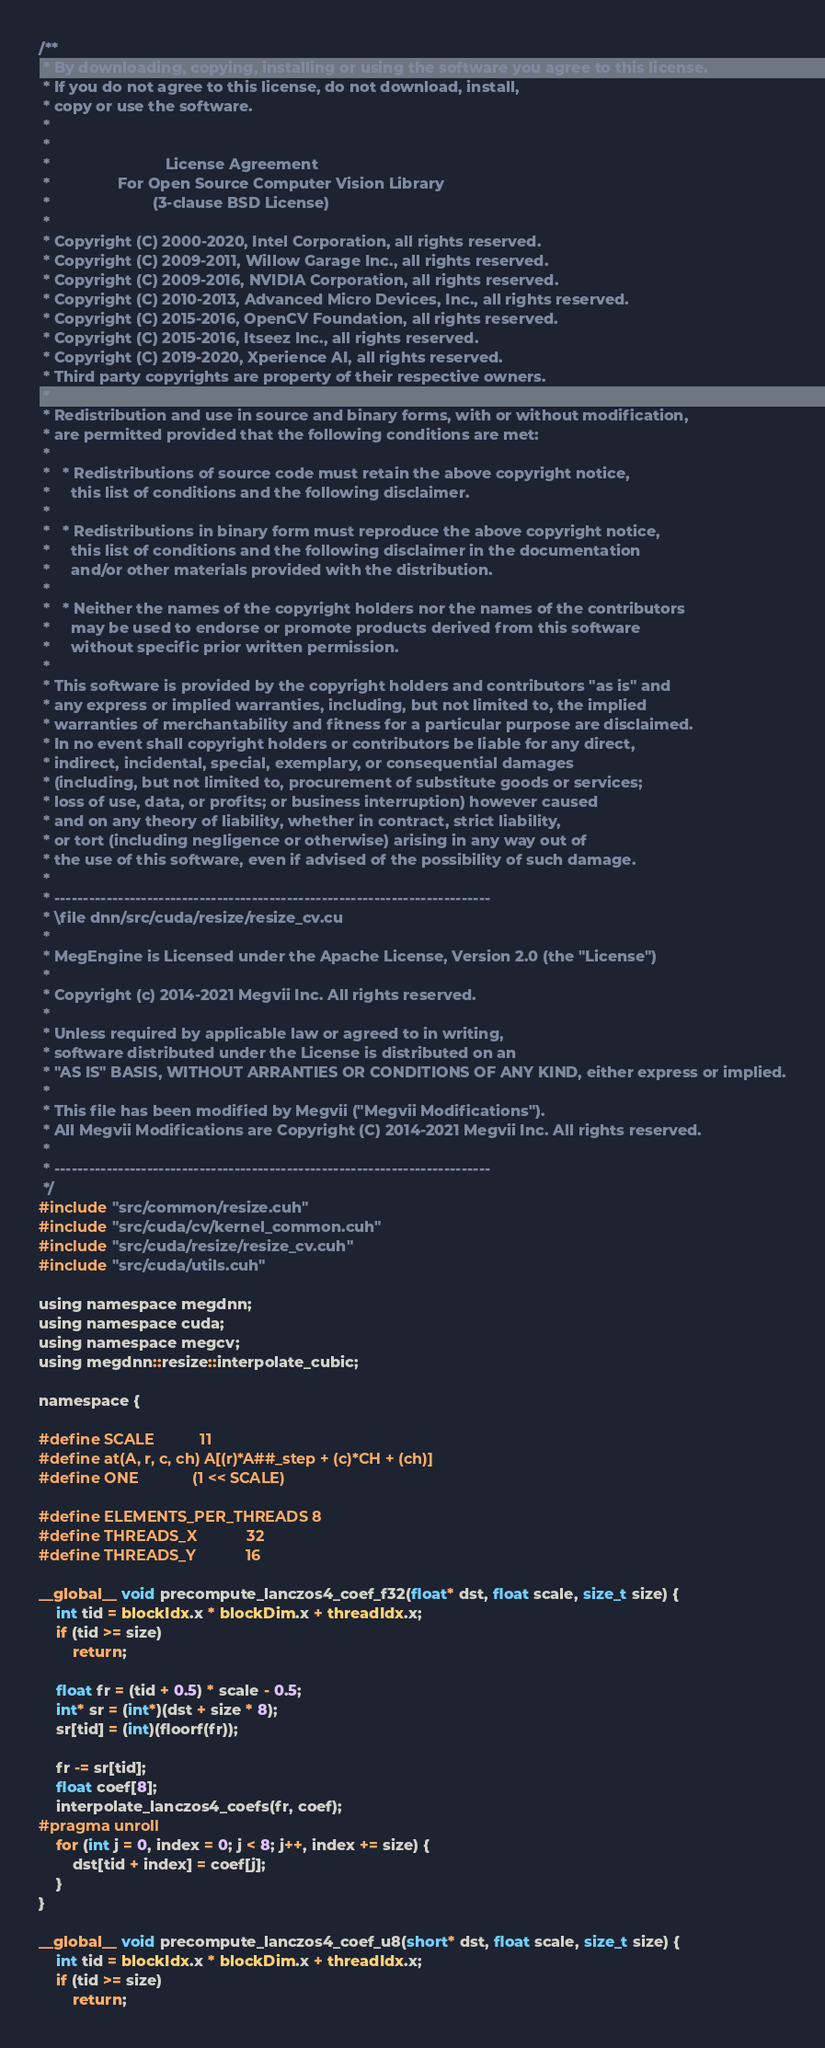Convert code to text. <code><loc_0><loc_0><loc_500><loc_500><_Cuda_>/**
 * By downloading, copying, installing or using the software you agree to this license.
 * If you do not agree to this license, do not download, install,
 * copy or use the software.
 *
 *
 *                           License Agreement
 *                For Open Source Computer Vision Library
 *                        (3-clause BSD License)
 *
 * Copyright (C) 2000-2020, Intel Corporation, all rights reserved.
 * Copyright (C) 2009-2011, Willow Garage Inc., all rights reserved.
 * Copyright (C) 2009-2016, NVIDIA Corporation, all rights reserved.
 * Copyright (C) 2010-2013, Advanced Micro Devices, Inc., all rights reserved.
 * Copyright (C) 2015-2016, OpenCV Foundation, all rights reserved.
 * Copyright (C) 2015-2016, Itseez Inc., all rights reserved.
 * Copyright (C) 2019-2020, Xperience AI, all rights reserved.
 * Third party copyrights are property of their respective owners.
 *
 * Redistribution and use in source and binary forms, with or without modification,
 * are permitted provided that the following conditions are met:
 *
 *   * Redistributions of source code must retain the above copyright notice,
 *     this list of conditions and the following disclaimer.
 *
 *   * Redistributions in binary form must reproduce the above copyright notice,
 *     this list of conditions and the following disclaimer in the documentation
 *     and/or other materials provided with the distribution.
 *
 *   * Neither the names of the copyright holders nor the names of the contributors
 *     may be used to endorse or promote products derived from this software
 *     without specific prior written permission.
 *
 * This software is provided by the copyright holders and contributors "as is" and
 * any express or implied warranties, including, but not limited to, the implied
 * warranties of merchantability and fitness for a particular purpose are disclaimed.
 * In no event shall copyright holders or contributors be liable for any direct,
 * indirect, incidental, special, exemplary, or consequential damages
 * (including, but not limited to, procurement of substitute goods or services;
 * loss of use, data, or profits; or business interruption) however caused
 * and on any theory of liability, whether in contract, strict liability,
 * or tort (including negligence or otherwise) arising in any way out of
 * the use of this software, even if advised of the possibility of such damage.
 *
 * ---------------------------------------------------------------------------
 * \file dnn/src/cuda/resize/resize_cv.cu
 *
 * MegEngine is Licensed under the Apache License, Version 2.0 (the "License")
 *
 * Copyright (c) 2014-2021 Megvii Inc. All rights reserved.
 *
 * Unless required by applicable law or agreed to in writing,
 * software distributed under the License is distributed on an
 * "AS IS" BASIS, WITHOUT ARRANTIES OR CONDITIONS OF ANY KIND, either express or implied.
 *
 * This file has been modified by Megvii ("Megvii Modifications").
 * All Megvii Modifications are Copyright (C) 2014-2021 Megvii Inc. All rights reserved.
 *
 * ---------------------------------------------------------------------------
 */
#include "src/common/resize.cuh"
#include "src/cuda/cv/kernel_common.cuh"
#include "src/cuda/resize/resize_cv.cuh"
#include "src/cuda/utils.cuh"

using namespace megdnn;
using namespace cuda;
using namespace megcv;
using megdnn::resize::interpolate_cubic;

namespace {

#define SCALE           11
#define at(A, r, c, ch) A[(r)*A##_step + (c)*CH + (ch)]
#define ONE             (1 << SCALE)

#define ELEMENTS_PER_THREADS 8
#define THREADS_X            32
#define THREADS_Y            16

__global__ void precompute_lanczos4_coef_f32(float* dst, float scale, size_t size) {
    int tid = blockIdx.x * blockDim.x + threadIdx.x;
    if (tid >= size)
        return;

    float fr = (tid + 0.5) * scale - 0.5;
    int* sr = (int*)(dst + size * 8);
    sr[tid] = (int)(floorf(fr));

    fr -= sr[tid];
    float coef[8];
    interpolate_lanczos4_coefs(fr, coef);
#pragma unroll
    for (int j = 0, index = 0; j < 8; j++, index += size) {
        dst[tid + index] = coef[j];
    }
}

__global__ void precompute_lanczos4_coef_u8(short* dst, float scale, size_t size) {
    int tid = blockIdx.x * blockDim.x + threadIdx.x;
    if (tid >= size)
        return;
</code> 